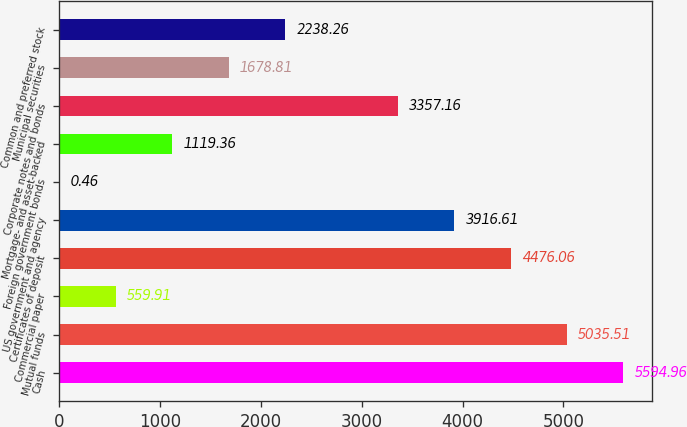<chart> <loc_0><loc_0><loc_500><loc_500><bar_chart><fcel>Cash<fcel>Mutual funds<fcel>Commercial paper<fcel>Certificates of deposit<fcel>US government and agency<fcel>Foreign government bonds<fcel>Mortgage- and asset-backed<fcel>Corporate notes and bonds<fcel>Municipal securities<fcel>Common and preferred stock<nl><fcel>5594.96<fcel>5035.51<fcel>559.91<fcel>4476.06<fcel>3916.61<fcel>0.46<fcel>1119.36<fcel>3357.16<fcel>1678.81<fcel>2238.26<nl></chart> 